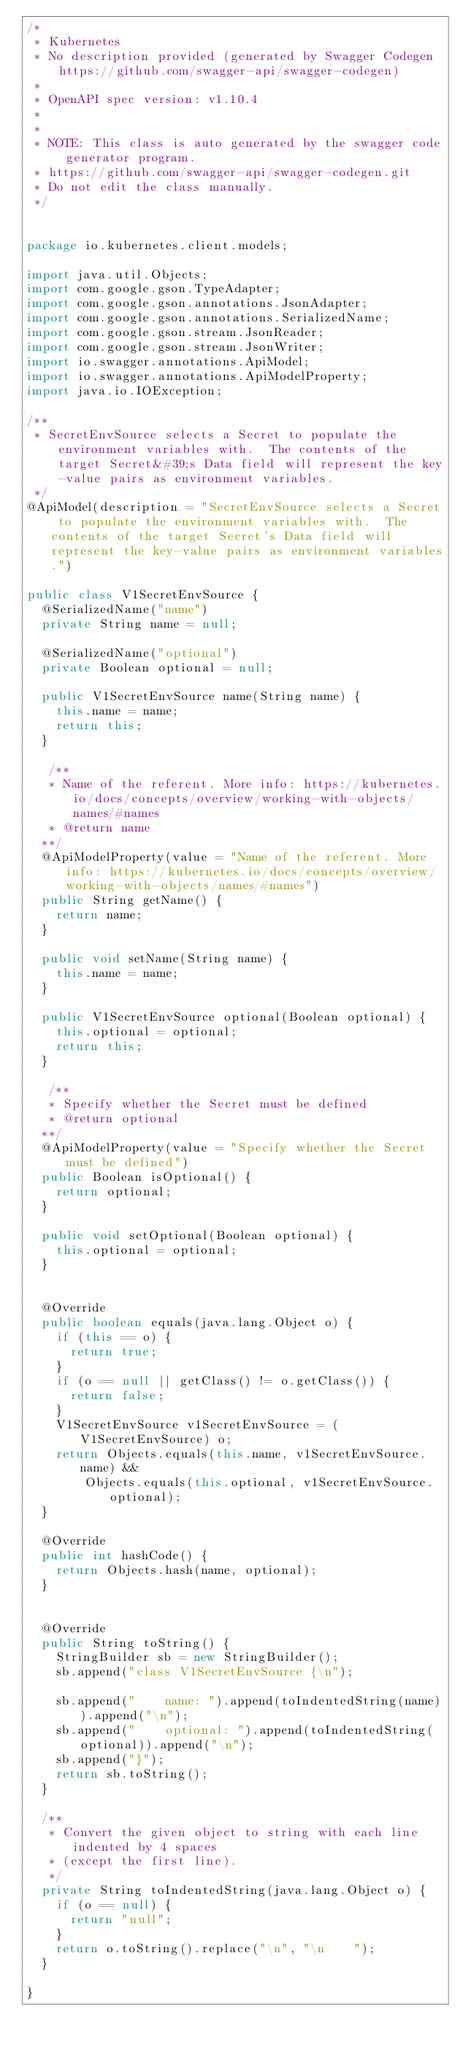Convert code to text. <code><loc_0><loc_0><loc_500><loc_500><_Java_>/*
 * Kubernetes
 * No description provided (generated by Swagger Codegen https://github.com/swagger-api/swagger-codegen)
 *
 * OpenAPI spec version: v1.10.4
 * 
 *
 * NOTE: This class is auto generated by the swagger code generator program.
 * https://github.com/swagger-api/swagger-codegen.git
 * Do not edit the class manually.
 */


package io.kubernetes.client.models;

import java.util.Objects;
import com.google.gson.TypeAdapter;
import com.google.gson.annotations.JsonAdapter;
import com.google.gson.annotations.SerializedName;
import com.google.gson.stream.JsonReader;
import com.google.gson.stream.JsonWriter;
import io.swagger.annotations.ApiModel;
import io.swagger.annotations.ApiModelProperty;
import java.io.IOException;

/**
 * SecretEnvSource selects a Secret to populate the environment variables with.  The contents of the target Secret&#39;s Data field will represent the key-value pairs as environment variables.
 */
@ApiModel(description = "SecretEnvSource selects a Secret to populate the environment variables with.  The contents of the target Secret's Data field will represent the key-value pairs as environment variables.")

public class V1SecretEnvSource {
  @SerializedName("name")
  private String name = null;

  @SerializedName("optional")
  private Boolean optional = null;

  public V1SecretEnvSource name(String name) {
    this.name = name;
    return this;
  }

   /**
   * Name of the referent. More info: https://kubernetes.io/docs/concepts/overview/working-with-objects/names/#names
   * @return name
  **/
  @ApiModelProperty(value = "Name of the referent. More info: https://kubernetes.io/docs/concepts/overview/working-with-objects/names/#names")
  public String getName() {
    return name;
  }

  public void setName(String name) {
    this.name = name;
  }

  public V1SecretEnvSource optional(Boolean optional) {
    this.optional = optional;
    return this;
  }

   /**
   * Specify whether the Secret must be defined
   * @return optional
  **/
  @ApiModelProperty(value = "Specify whether the Secret must be defined")
  public Boolean isOptional() {
    return optional;
  }

  public void setOptional(Boolean optional) {
    this.optional = optional;
  }


  @Override
  public boolean equals(java.lang.Object o) {
    if (this == o) {
      return true;
    }
    if (o == null || getClass() != o.getClass()) {
      return false;
    }
    V1SecretEnvSource v1SecretEnvSource = (V1SecretEnvSource) o;
    return Objects.equals(this.name, v1SecretEnvSource.name) &&
        Objects.equals(this.optional, v1SecretEnvSource.optional);
  }

  @Override
  public int hashCode() {
    return Objects.hash(name, optional);
  }


  @Override
  public String toString() {
    StringBuilder sb = new StringBuilder();
    sb.append("class V1SecretEnvSource {\n");
    
    sb.append("    name: ").append(toIndentedString(name)).append("\n");
    sb.append("    optional: ").append(toIndentedString(optional)).append("\n");
    sb.append("}");
    return sb.toString();
  }

  /**
   * Convert the given object to string with each line indented by 4 spaces
   * (except the first line).
   */
  private String toIndentedString(java.lang.Object o) {
    if (o == null) {
      return "null";
    }
    return o.toString().replace("\n", "\n    ");
  }

}

</code> 